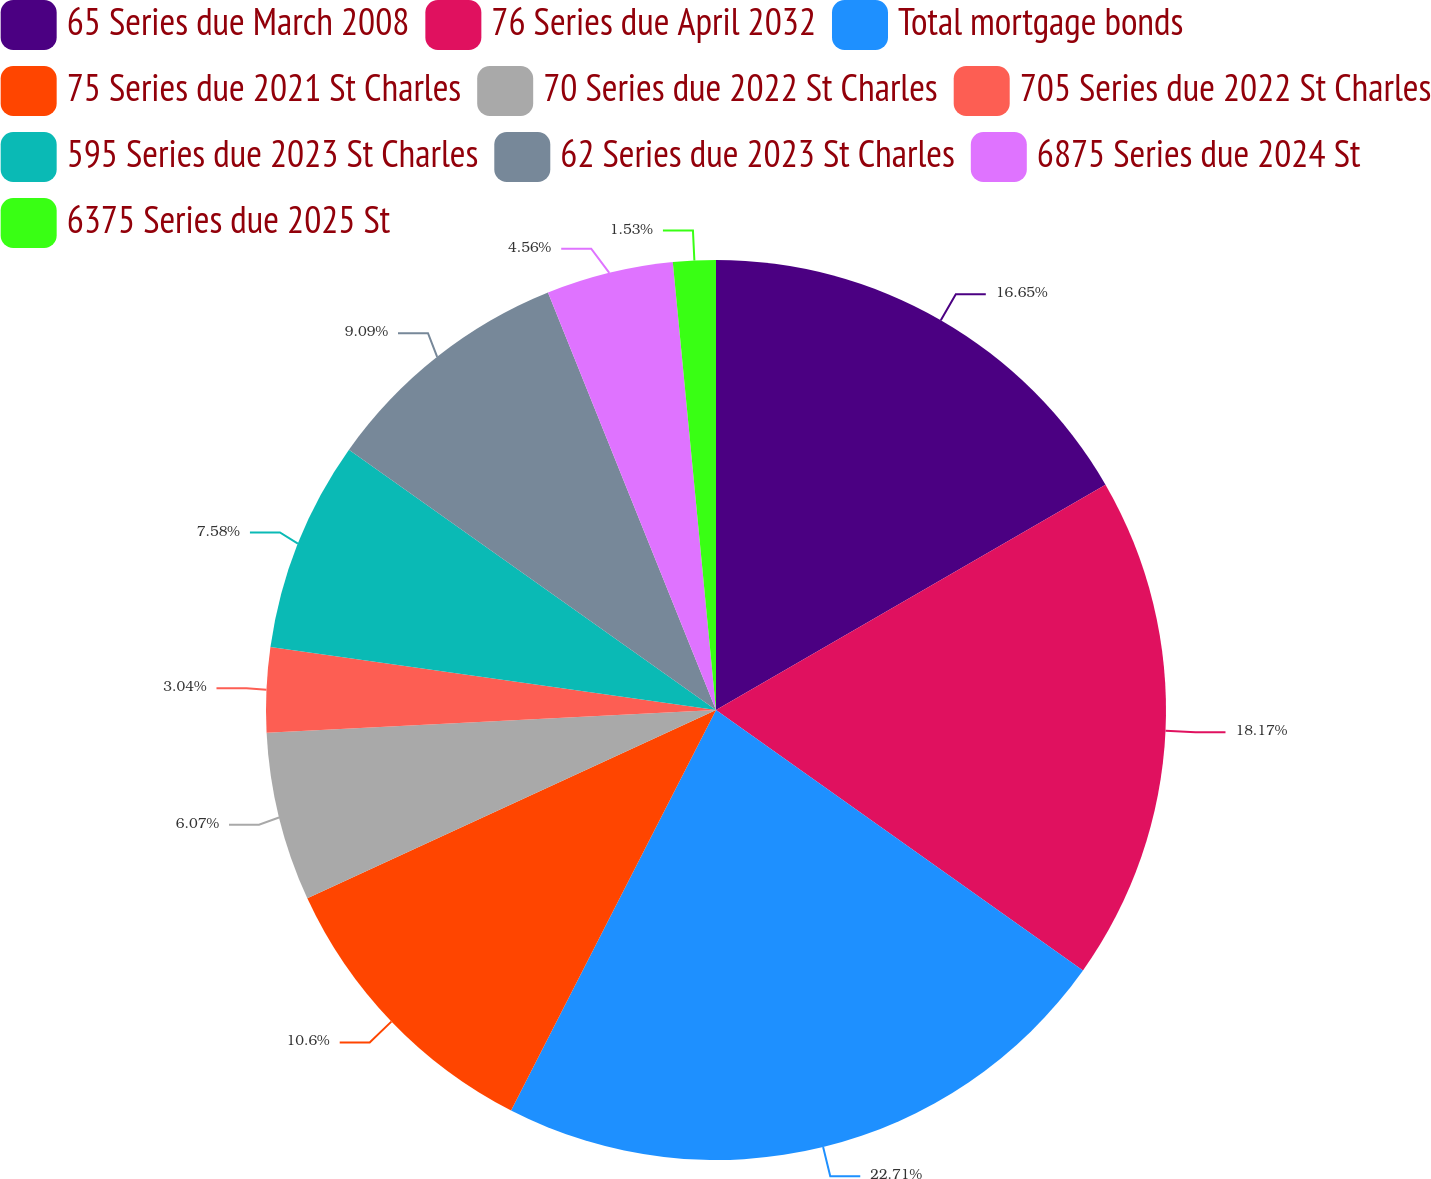Convert chart to OTSL. <chart><loc_0><loc_0><loc_500><loc_500><pie_chart><fcel>65 Series due March 2008<fcel>76 Series due April 2032<fcel>Total mortgage bonds<fcel>75 Series due 2021 St Charles<fcel>70 Series due 2022 St Charles<fcel>705 Series due 2022 St Charles<fcel>595 Series due 2023 St Charles<fcel>62 Series due 2023 St Charles<fcel>6875 Series due 2024 St<fcel>6375 Series due 2025 St<nl><fcel>16.65%<fcel>18.17%<fcel>22.7%<fcel>10.6%<fcel>6.07%<fcel>3.04%<fcel>7.58%<fcel>9.09%<fcel>4.56%<fcel>1.53%<nl></chart> 